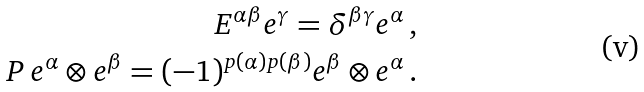<formula> <loc_0><loc_0><loc_500><loc_500>E ^ { \alpha \beta } e ^ { \gamma } = \delta ^ { \beta \gamma } e ^ { \alpha } \, , \\ P \, e ^ { \alpha } \otimes e ^ { \beta } = ( - 1 ) ^ { p ( \alpha ) p ( \beta ) } e ^ { \beta } \otimes e ^ { \alpha } \, .</formula> 